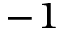Convert formula to latex. <formula><loc_0><loc_0><loc_500><loc_500>^ { - 1 }</formula> 